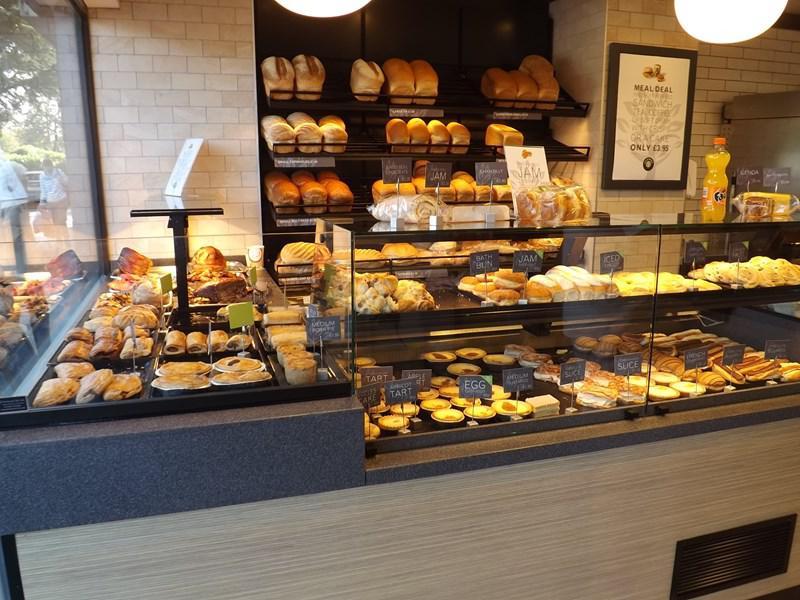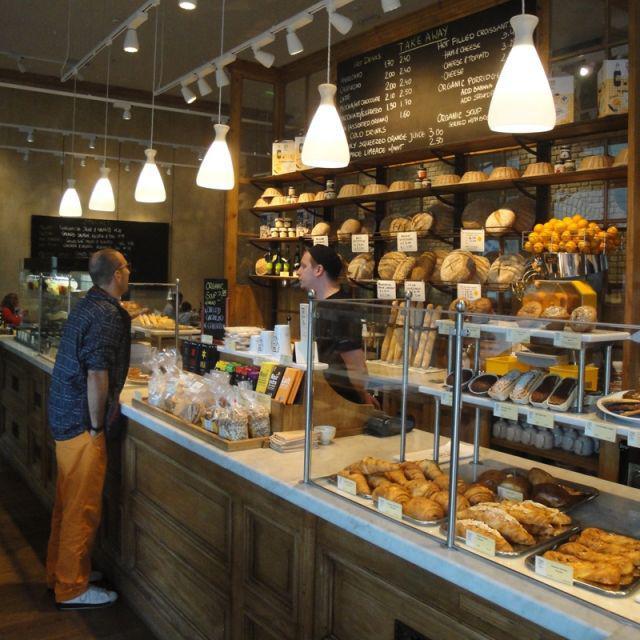The first image is the image on the left, the second image is the image on the right. Considering the images on both sides, is "At least five pendant lights hang over one of the bakery display images." valid? Answer yes or no. Yes. The first image is the image on the left, the second image is the image on the right. Given the left and right images, does the statement "People are standing near a case of baked goods" hold true? Answer yes or no. Yes. 